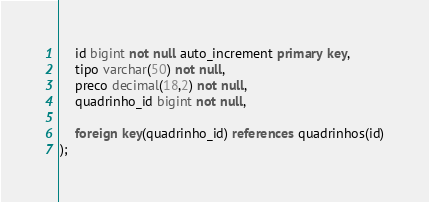<code> <loc_0><loc_0><loc_500><loc_500><_SQL_>	id bigint not null auto_increment primary key,
	tipo varchar(50) not null,
	preco decimal(18,2) not null,
	quadrinho_id bigint not null,
	
	foreign key(quadrinho_id) references quadrinhos(id)
);</code> 